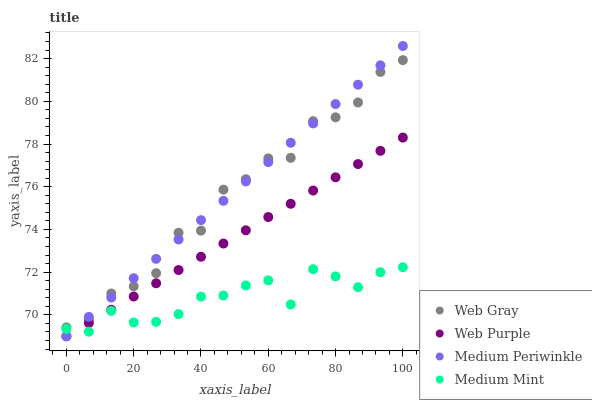Does Medium Mint have the minimum area under the curve?
Answer yes or no. Yes. Does Medium Periwinkle have the maximum area under the curve?
Answer yes or no. Yes. Does Web Purple have the minimum area under the curve?
Answer yes or no. No. Does Web Purple have the maximum area under the curve?
Answer yes or no. No. Is Medium Periwinkle the smoothest?
Answer yes or no. Yes. Is Web Gray the roughest?
Answer yes or no. Yes. Is Web Purple the smoothest?
Answer yes or no. No. Is Web Purple the roughest?
Answer yes or no. No. Does Web Purple have the lowest value?
Answer yes or no. Yes. Does Web Gray have the lowest value?
Answer yes or no. No. Does Medium Periwinkle have the highest value?
Answer yes or no. Yes. Does Web Purple have the highest value?
Answer yes or no. No. Is Medium Mint less than Web Gray?
Answer yes or no. Yes. Is Web Gray greater than Medium Mint?
Answer yes or no. Yes. Does Medium Mint intersect Web Purple?
Answer yes or no. Yes. Is Medium Mint less than Web Purple?
Answer yes or no. No. Is Medium Mint greater than Web Purple?
Answer yes or no. No. Does Medium Mint intersect Web Gray?
Answer yes or no. No. 